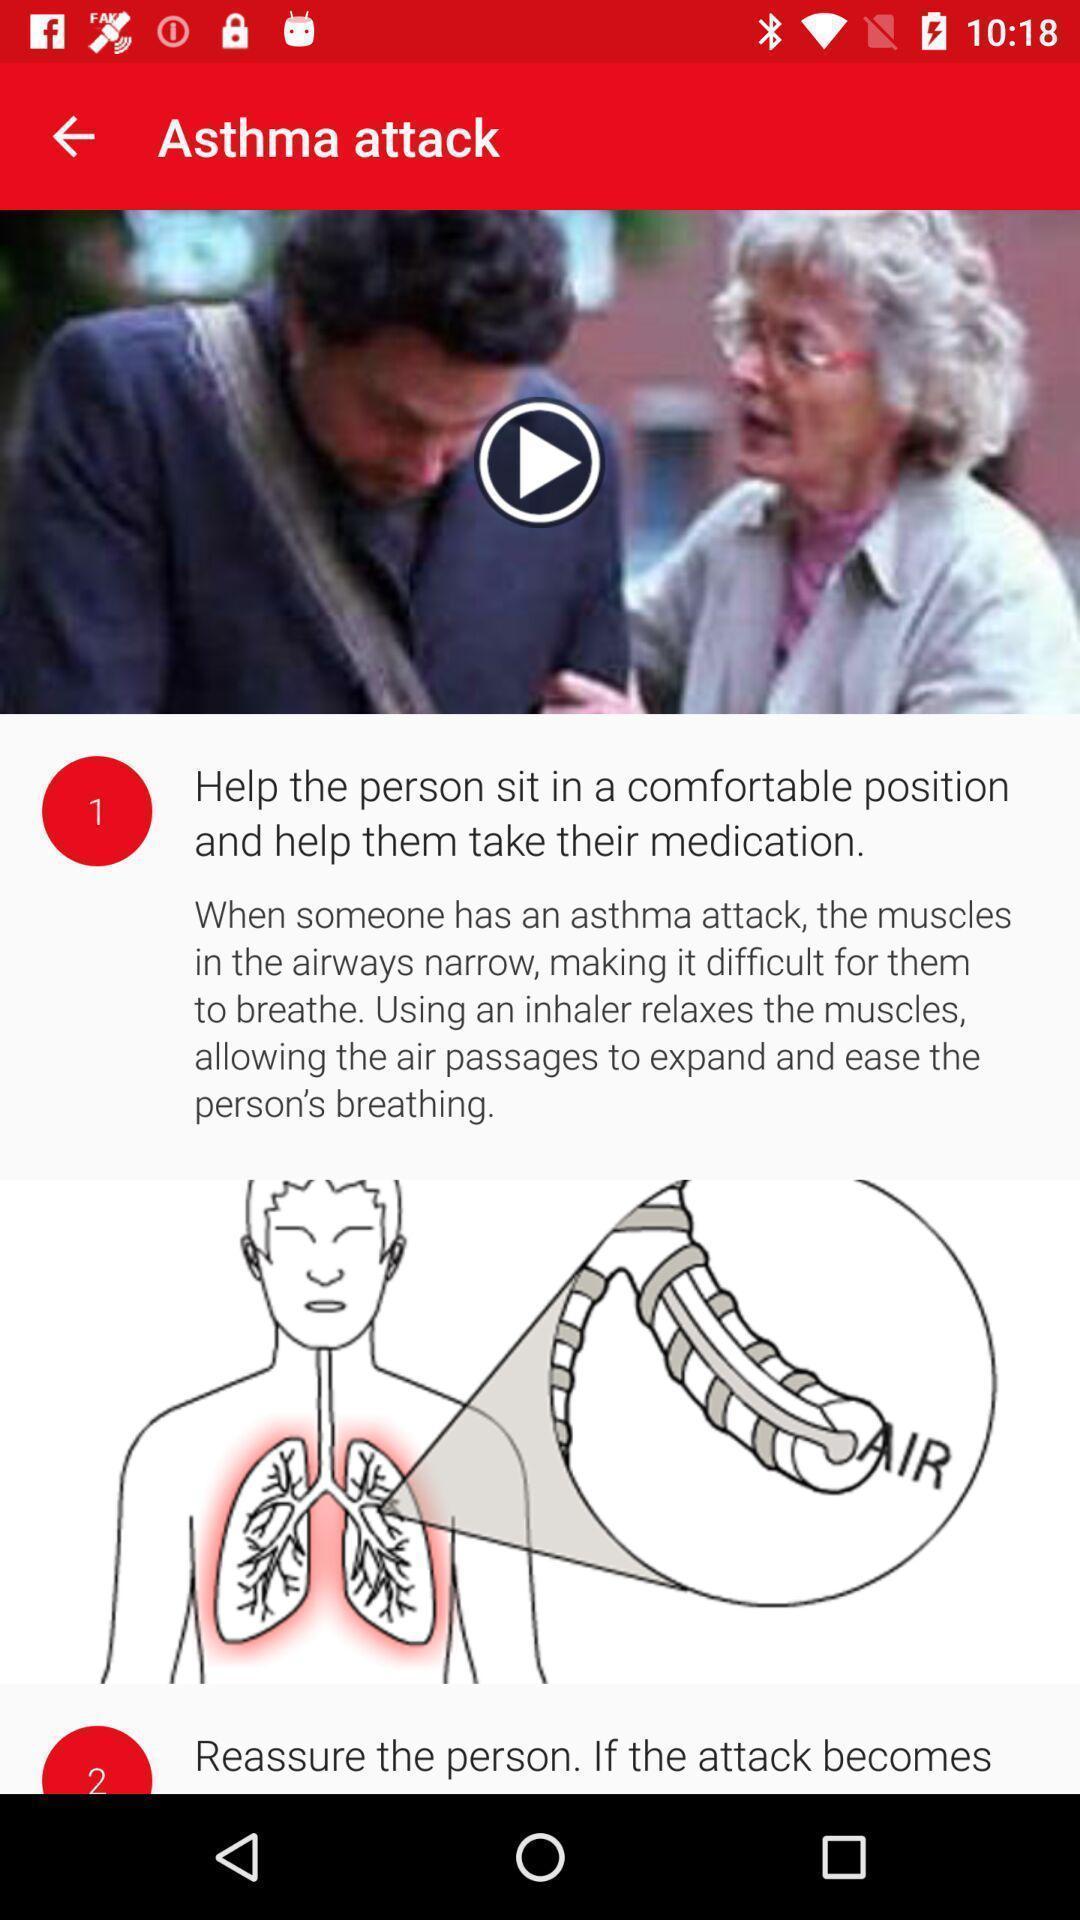Please provide a description for this image. Page showing steps of a procedure in the medical app. 